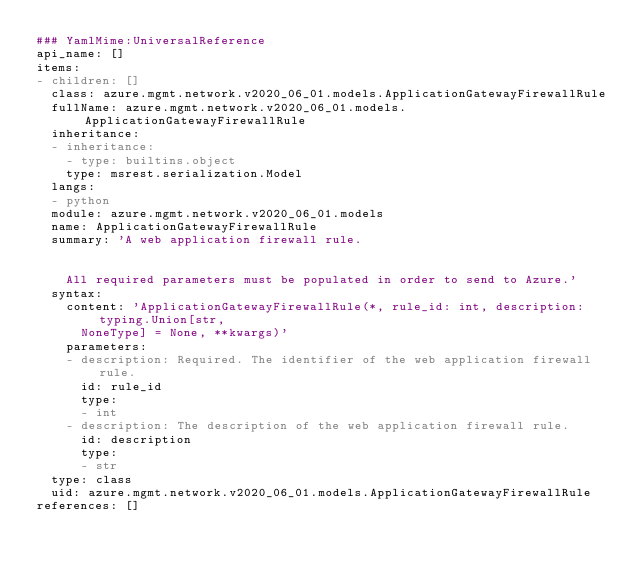<code> <loc_0><loc_0><loc_500><loc_500><_YAML_>### YamlMime:UniversalReference
api_name: []
items:
- children: []
  class: azure.mgmt.network.v2020_06_01.models.ApplicationGatewayFirewallRule
  fullName: azure.mgmt.network.v2020_06_01.models.ApplicationGatewayFirewallRule
  inheritance:
  - inheritance:
    - type: builtins.object
    type: msrest.serialization.Model
  langs:
  - python
  module: azure.mgmt.network.v2020_06_01.models
  name: ApplicationGatewayFirewallRule
  summary: 'A web application firewall rule.


    All required parameters must be populated in order to send to Azure.'
  syntax:
    content: 'ApplicationGatewayFirewallRule(*, rule_id: int, description: typing.Union[str,
      NoneType] = None, **kwargs)'
    parameters:
    - description: Required. The identifier of the web application firewall rule.
      id: rule_id
      type:
      - int
    - description: The description of the web application firewall rule.
      id: description
      type:
      - str
  type: class
  uid: azure.mgmt.network.v2020_06_01.models.ApplicationGatewayFirewallRule
references: []
</code> 